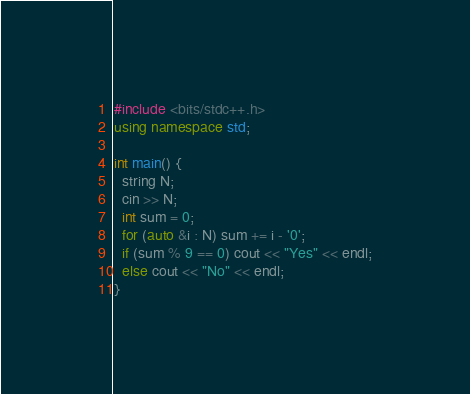Convert code to text. <code><loc_0><loc_0><loc_500><loc_500><_C++_>#include <bits/stdc++.h>
using namespace std;

int main() {
  string N;
  cin >> N;
  int sum = 0;
  for (auto &i : N) sum += i - '0';
  if (sum % 9 == 0) cout << "Yes" << endl;
  else cout << "No" << endl;
}</code> 